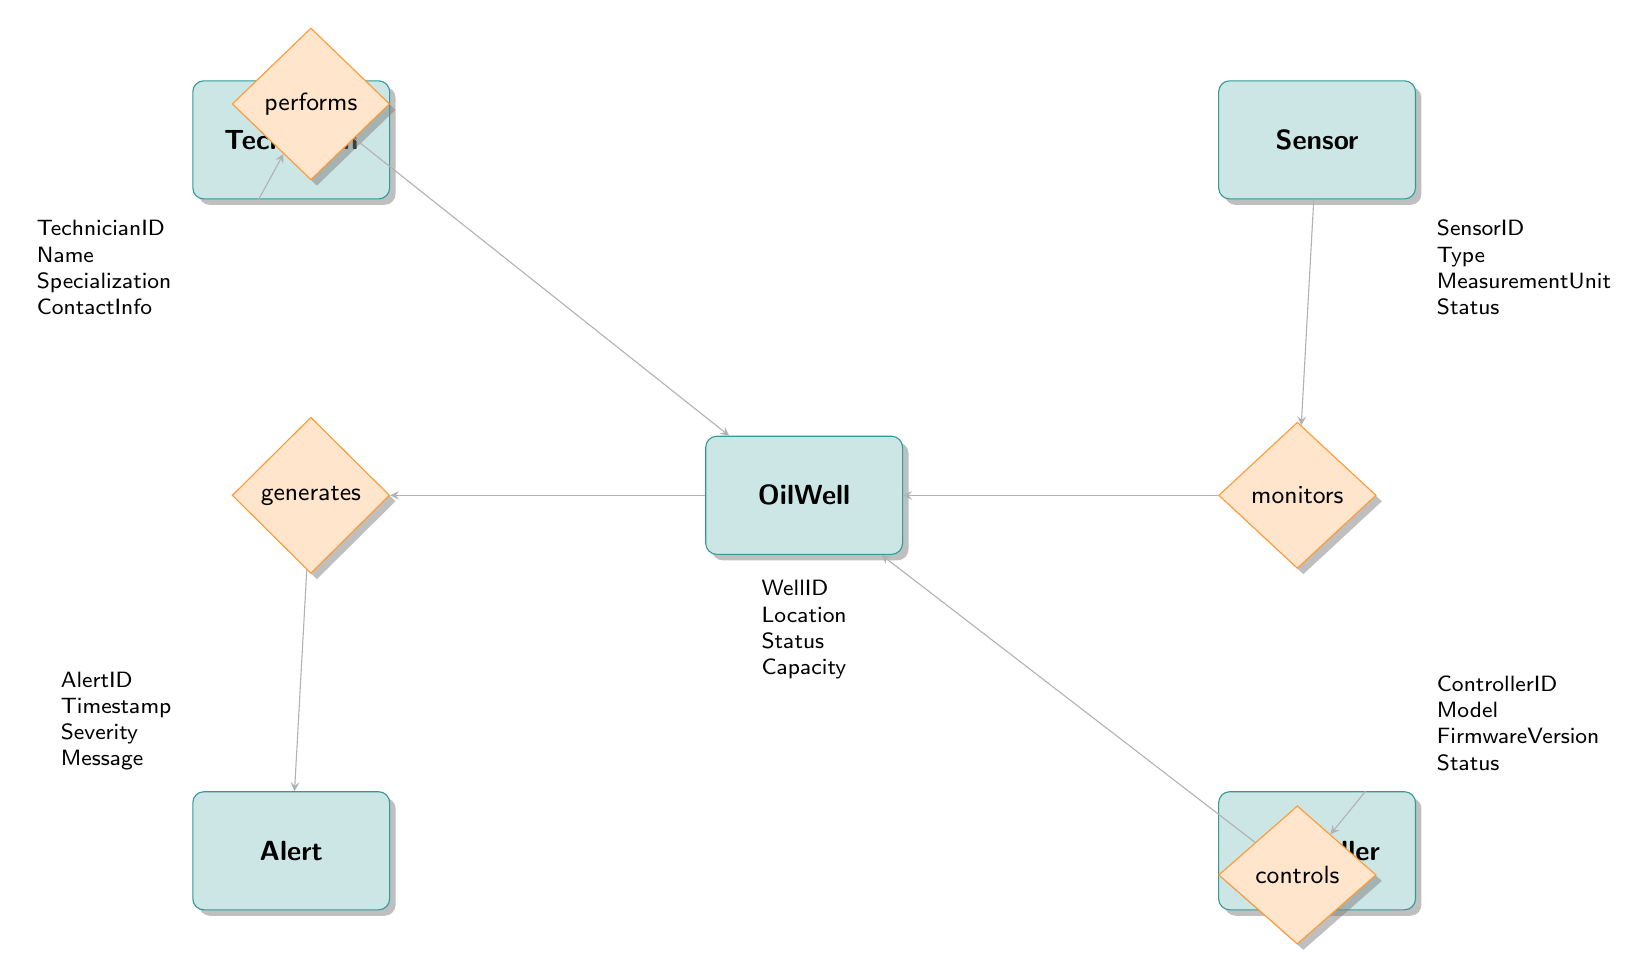What is the capacity attribute of the OilWell entity? By looking at the OilWell entity, we can see that "Capacity" is one of its listed attributes. However, the diagram does not provide a specific value, hence we cannot determine a numeric answer from the diagram itself; we only know "Capacity" is an attribute.
Answer: Capacity How many entities are represented in the diagram? There are a total of six entities in the diagram: OilWell, Sensor, Controller, Alert, MaintenanceLog, and Technician. This count can be verified by visually counting each unique rectangle labeled as an entity.
Answer: Six What is the name of the relationship that links Sensor and OilWell? The diagram indicates that the relationship between Sensor and OilWell is labeled "monitors." This can be seen next to the arrow connecting the two entities.
Answer: monitors Which entity is connected to the Controller entity? The diagram shows that the Controller entity is connected to the OilWell entity through the "controls" relationship. This information is derived from the direct arrow leading from Controller to this relationship, then to OilWell.
Answer: OilWell What is the action taken noted in the MaintenanceLog with respect to Technician? The diagram indicates that the relationship between Technician and MaintenanceLog is recorded through "records." This suggests that the actions taken by Technicians are logged in relation to well maintenance details, but does not specify a single action in the diagram.
Answer: records Who generates alerts for the OilWell? The diagram clearly portrays that "OilWell" is connected to "Alert" via the relationship labeled "generates". Therefore, it is the OilWell that generates alerts, as indicated by the flow of the relationship.
Answer: OilWell What attributes does the Sensor entity contain? The Sensor entity lists the following attributes: SensorID, Type, MeasurementUnit, and Status. These can be noted from the labels listed under the Sensor rectangle.
Answer: SensorID, Type, MeasurementUnit, Status What does the Technician entity link to regarding OilWell? The Technician entity is linked to OilWell through the relationship labeled "performs." This means that Technicians perform actions related to the OilWell. This connection can be traced through the direction of the arrows in the diagram.
Answer: performs What does the Alert entity record about the event? The Alert entity contains the attributes AlertID, Timestamp, Severity, and Message, indicating it captures details when an alert is generated. This understanding arises from the attributes listed under the Alert rectangle in the diagram.
Answer: AlertID, Timestamp, Severity, Message 